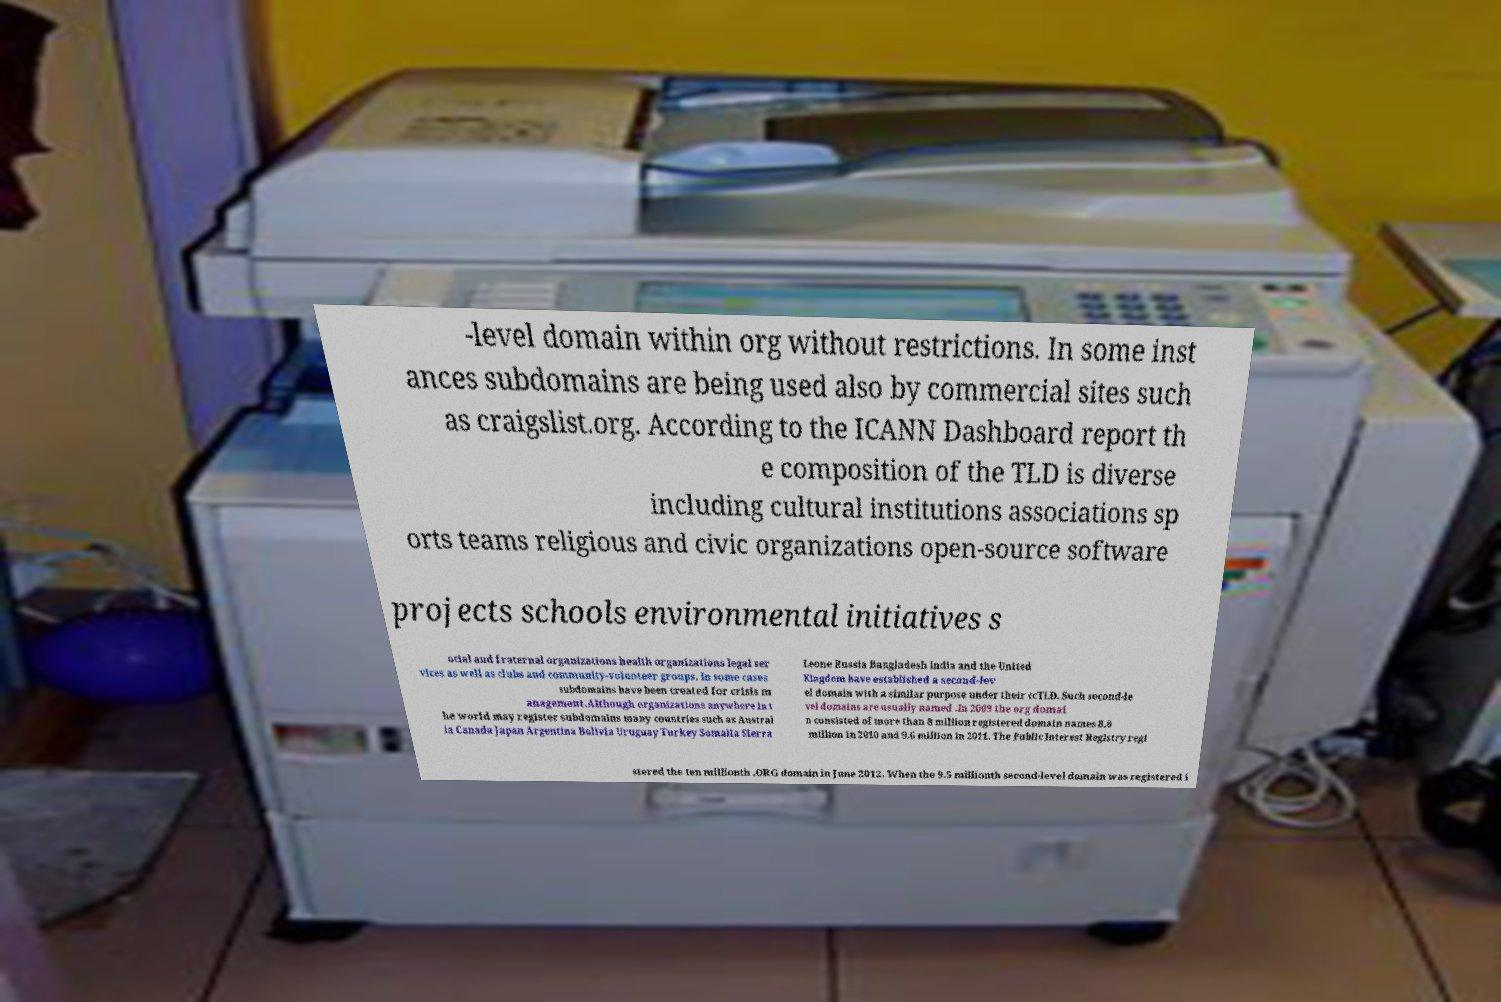For documentation purposes, I need the text within this image transcribed. Could you provide that? -level domain within org without restrictions. In some inst ances subdomains are being used also by commercial sites such as craigslist.org. According to the ICANN Dashboard report th e composition of the TLD is diverse including cultural institutions associations sp orts teams religious and civic organizations open-source software projects schools environmental initiatives s ocial and fraternal organizations health organizations legal ser vices as well as clubs and community-volunteer groups. In some cases subdomains have been created for crisis m anagement.Although organizations anywhere in t he world may register subdomains many countries such as Austral ia Canada Japan Argentina Bolivia Uruguay Turkey Somalia Sierra Leone Russia Bangladesh India and the United Kingdom have established a second-lev el domain with a similar purpose under their ccTLD. Such second-le vel domains are usually named .In 2009 the org domai n consisted of more than 8 million registered domain names 8.8 million in 2010 and 9.6 million in 2011. The Public Interest Registry regi stered the ten millionth .ORG domain in June 2012. When the 9.5 millionth second-level domain was registered i 